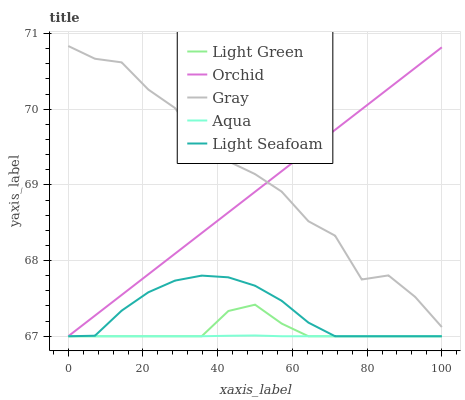Does Aqua have the minimum area under the curve?
Answer yes or no. Yes. Does Gray have the maximum area under the curve?
Answer yes or no. Yes. Does Light Seafoam have the minimum area under the curve?
Answer yes or no. No. Does Light Seafoam have the maximum area under the curve?
Answer yes or no. No. Is Orchid the smoothest?
Answer yes or no. Yes. Is Gray the roughest?
Answer yes or no. Yes. Is Light Seafoam the smoothest?
Answer yes or no. No. Is Light Seafoam the roughest?
Answer yes or no. No. Does Light Seafoam have the highest value?
Answer yes or no. No. Is Aqua less than Gray?
Answer yes or no. Yes. Is Gray greater than Light Green?
Answer yes or no. Yes. Does Aqua intersect Gray?
Answer yes or no. No. 